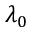<formula> <loc_0><loc_0><loc_500><loc_500>\lambda _ { 0 }</formula> 